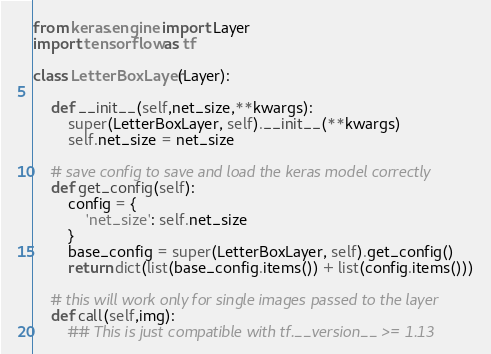<code> <loc_0><loc_0><loc_500><loc_500><_Python_>from keras.engine import Layer
import tensorflow as tf

class LetterBoxLayer(Layer):

    def __init__(self,net_size,**kwargs):
        super(LetterBoxLayer, self).__init__(**kwargs)
        self.net_size = net_size

    # save config to save and load the keras model correctly
    def get_config(self):
        config = {
            'net_size': self.net_size
        }
        base_config = super(LetterBoxLayer, self).get_config()
        return dict(list(base_config.items()) + list(config.items()))

    # this will work only for single images passed to the layer
    def call(self,img):
        ## This is just compatible with tf.__version__ >= 1.13</code> 